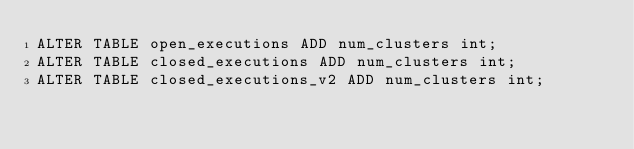<code> <loc_0><loc_0><loc_500><loc_500><_SQL_>ALTER TABLE open_executions ADD num_clusters int;
ALTER TABLE closed_executions ADD num_clusters int;
ALTER TABLE closed_executions_v2 ADD num_clusters int;
</code> 